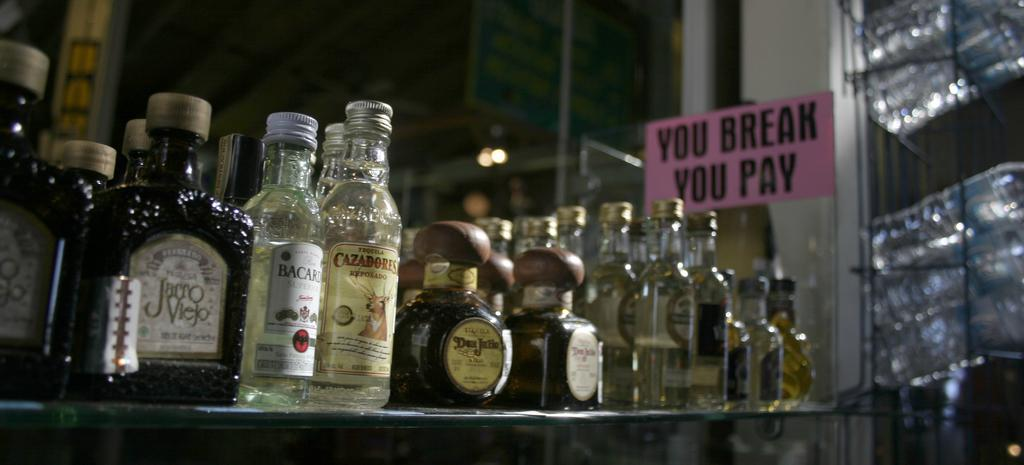<image>
Present a compact description of the photo's key features. bottles of liquor near a sign reading You Break You Pay 